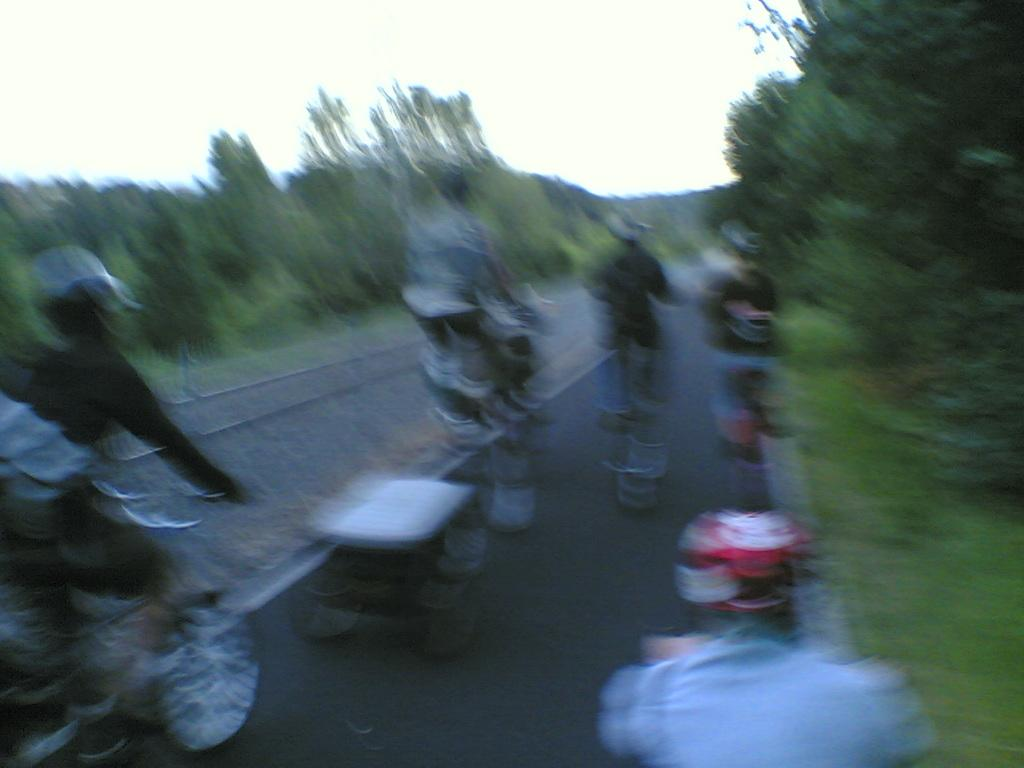Who or what can be seen in the image? There are people in the image. What are the people doing in the image? The people are riding bicycles. Where are the bicycles located? The bicycles are on a road. What can be seen in the background of the image? There are trees in the background of the image. Can you see a plane flying in the image? There is no plane visible in the image; it only shows people riding bicycles on a road with trees in the background. 